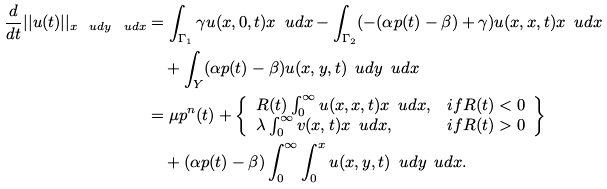<formula> <loc_0><loc_0><loc_500><loc_500>\frac { d } { d t } | | u ( t ) | | _ { x \, \ u d y \, \ u d x } & = \int _ { \Gamma _ { 1 } } \gamma u ( x , 0 , t ) x \, \ u d x - \int _ { \Gamma _ { 2 } } ( - ( \alpha p ( t ) - \beta ) + \gamma ) u ( x , x , t ) x \, \ u d x \\ & \quad + \int _ { Y } ( \alpha p ( t ) - \beta ) u ( x , y , t ) \, \ u d y \, \ u d x \\ & = \mu p ^ { n } ( t ) + \left \{ \begin{array} { l l } R ( t ) \int _ { 0 } ^ { \infty } u ( x , x , t ) x \, \ u d x , & i f R ( t ) < 0 \\ \lambda \int _ { 0 } ^ { \infty } v ( x , t ) x \, \ u d x , & i f R ( t ) > 0 \end{array} \right \} \\ & \quad + ( \alpha p ( t ) - \beta ) \int _ { 0 } ^ { \infty } \int _ { 0 } ^ { x } u ( x , y , t ) \, \ u d y \, \ u d x .</formula> 